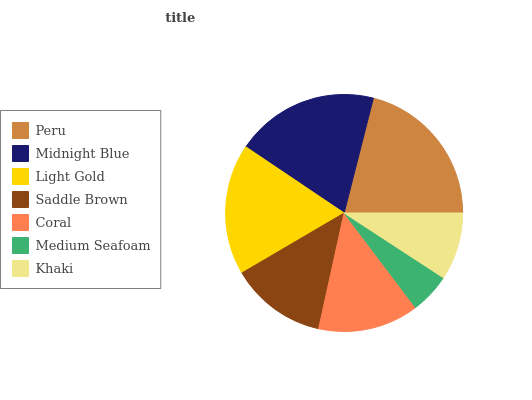Is Medium Seafoam the minimum?
Answer yes or no. Yes. Is Peru the maximum?
Answer yes or no. Yes. Is Midnight Blue the minimum?
Answer yes or no. No. Is Midnight Blue the maximum?
Answer yes or no. No. Is Peru greater than Midnight Blue?
Answer yes or no. Yes. Is Midnight Blue less than Peru?
Answer yes or no. Yes. Is Midnight Blue greater than Peru?
Answer yes or no. No. Is Peru less than Midnight Blue?
Answer yes or no. No. Is Coral the high median?
Answer yes or no. Yes. Is Coral the low median?
Answer yes or no. Yes. Is Saddle Brown the high median?
Answer yes or no. No. Is Khaki the low median?
Answer yes or no. No. 